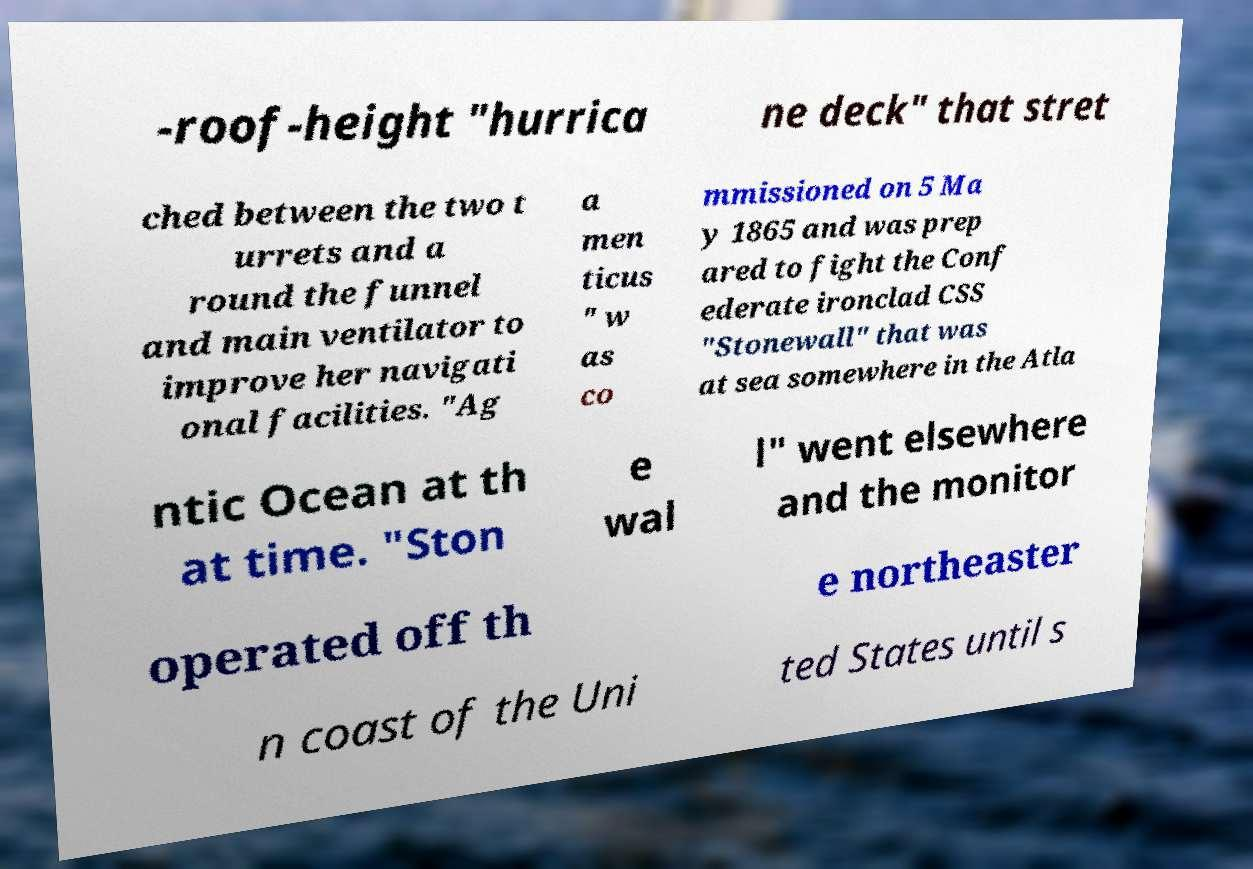I need the written content from this picture converted into text. Can you do that? -roof-height "hurrica ne deck" that stret ched between the two t urrets and a round the funnel and main ventilator to improve her navigati onal facilities. "Ag a men ticus " w as co mmissioned on 5 Ma y 1865 and was prep ared to fight the Conf ederate ironclad CSS "Stonewall" that was at sea somewhere in the Atla ntic Ocean at th at time. "Ston e wal l" went elsewhere and the monitor operated off th e northeaster n coast of the Uni ted States until s 